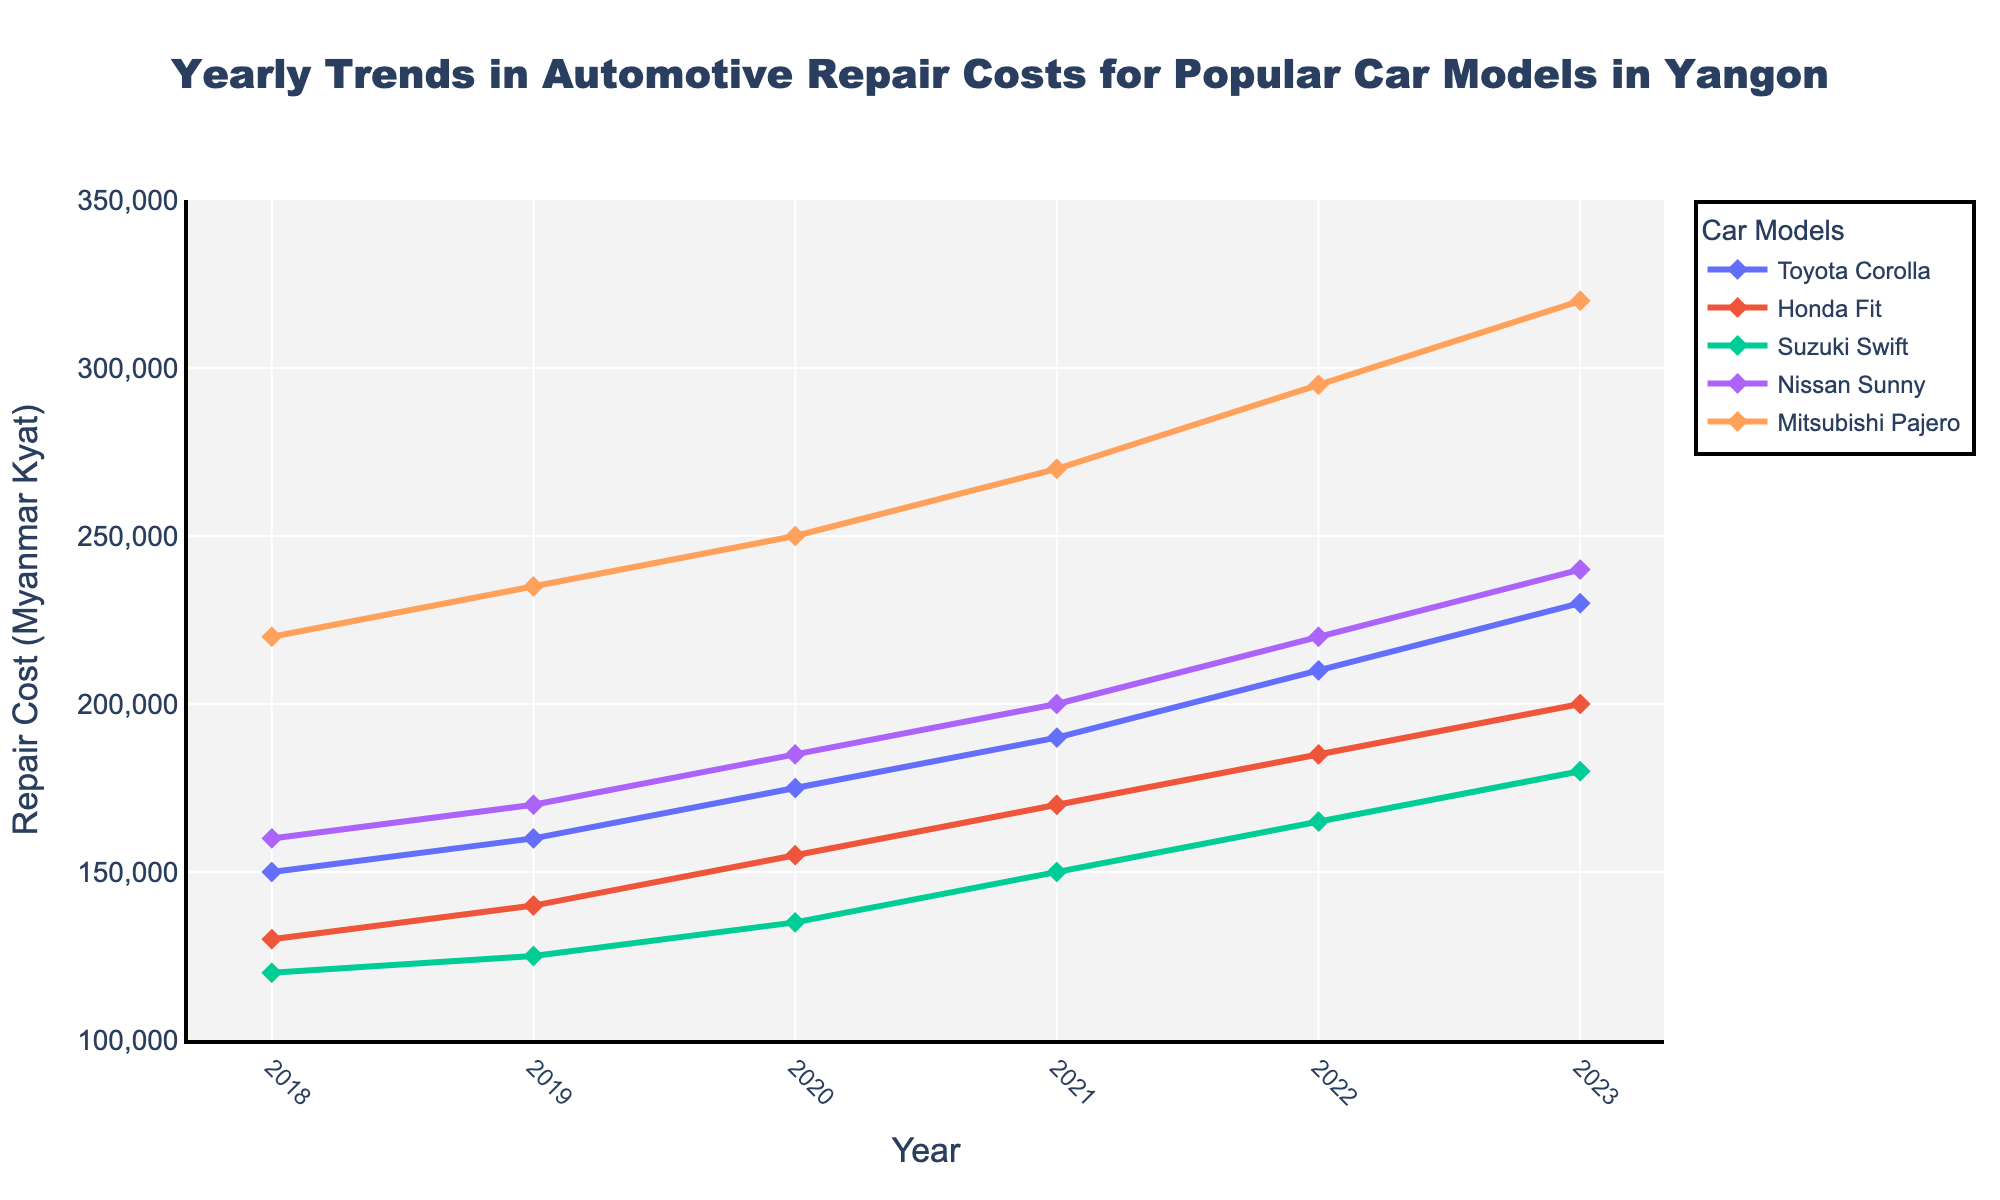Which car model had the highest repair cost in 2023? By examining the highest point on the Y-axis for 2023, we can see that the Mitsubishi Pajero had the highest repair cost compared to the other models.
Answer: Mitsubishi Pajero Which car model experienced the greatest increase in repair costs from 2018 to 2023? The difference in repair costs between 2018 and 2023 for each model is as follows: 
Toyota Corolla: (230000-150000) = 80000 
Honda Fit: (200000-130000) = 70000
Suzuki Swift: (180000-120000) = 60000 
Nissan Sunny: (240000-160000) = 80000
Mitsubishi Pajero: (320000-220000) = 100000
The Mitsubishi Pajero experienced the greatest increase.
Answer: Mitsubishi Pajero Which car model had the least change in repair costs between any two consecutive years? By examining the changes between consecutive years for each model visually:
Toyota Corolla changes: 10000, 15000, 15000, 20000, 20000 
Honda Fit changes: 10000, 15000, 15000, 15000, 15000 
Suzuki Swift changes: 5000, 10000, 15000, 15000, 15000 
Nissan Sunny changes: 10000, 15000, 15000, 20000, 20000 
Mitsubishi Pajero changes: 15000, 15000, 20000, 25000, 25000
Suzuki Swift has the least change of 5000 between 2018 and 2019, where the cost went from 120000 to 125000.
Answer: Suzuki Swift Which year saw a significant overall increase in repair costs across most car models? By comparing the year-on-year increments across all models:
2018-2019: (+10,000 to +15,000)
2019-2020: (+10,000 to +15,000)
2020-2021: (+15,000 to +20,000)
2021-2022: (+20,000 to +25,000)
2022-2023: (+20,000 to +25,000)
Years 2021-2022 and 2022-2023 saw a significant increase overall across all models. The largest overall increment appears consistently in these recent years.
Answer: 2021-2022, 2022-2023 Which car model showed the steadiest upward trend in repair costs over the years? By observing the smoothness and consistency of the trend lines:
Toyota Corolla: steady increments 
Honda Fit: steady increments 
Suzuki Swift: steady increments 
Nissan Sunny: steady increments 
Mitsubishi Pajero: relatively steadiest but slightly higher annual increments 
Toyota Corolla, Honda Fit, Suzuki Swift, and Nissan Sunny all show fairly steady trends, but the Toyota Corolla shows the smoothest consistent trend.
Answer: Toyota Corolla What was the average repair cost for Honda Fit over all the years? The repair costs for Honda Fit across the years are: 130000, 140000, 155000, 170000, 185000, and 200000.
Sum = 130000 + 140000 + 155000 + 170000 + 185000 + 200000 = 980000
Average = 980000 / 6 = 163333.33
Answer: 163333.33 